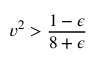<formula> <loc_0><loc_0><loc_500><loc_500>v ^ { 2 } > \frac { 1 - \epsilon } { 8 + \epsilon }</formula> 